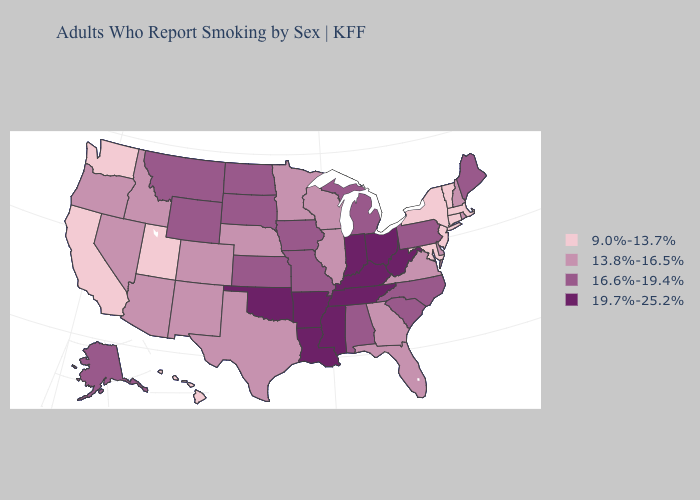Which states have the lowest value in the West?
Short answer required. California, Hawaii, Utah, Washington. Among the states that border Delaware , which have the lowest value?
Be succinct. Maryland, New Jersey. Does Iowa have the same value as Ohio?
Be succinct. No. Among the states that border Missouri , which have the highest value?
Short answer required. Arkansas, Kentucky, Oklahoma, Tennessee. What is the value of Oklahoma?
Quick response, please. 19.7%-25.2%. What is the highest value in the Northeast ?
Keep it brief. 16.6%-19.4%. How many symbols are there in the legend?
Short answer required. 4. What is the highest value in states that border Maine?
Concise answer only. 13.8%-16.5%. Among the states that border Nebraska , does Wyoming have the lowest value?
Quick response, please. No. What is the value of Rhode Island?
Write a very short answer. 13.8%-16.5%. What is the highest value in states that border Ohio?
Answer briefly. 19.7%-25.2%. What is the lowest value in the South?
Give a very brief answer. 9.0%-13.7%. Name the states that have a value in the range 16.6%-19.4%?
Answer briefly. Alabama, Alaska, Iowa, Kansas, Maine, Michigan, Missouri, Montana, North Carolina, North Dakota, Pennsylvania, South Carolina, South Dakota, Wyoming. Name the states that have a value in the range 13.8%-16.5%?
Give a very brief answer. Arizona, Colorado, Delaware, Florida, Georgia, Idaho, Illinois, Minnesota, Nebraska, Nevada, New Hampshire, New Mexico, Oregon, Rhode Island, Texas, Virginia, Wisconsin. What is the value of Montana?
Write a very short answer. 16.6%-19.4%. 